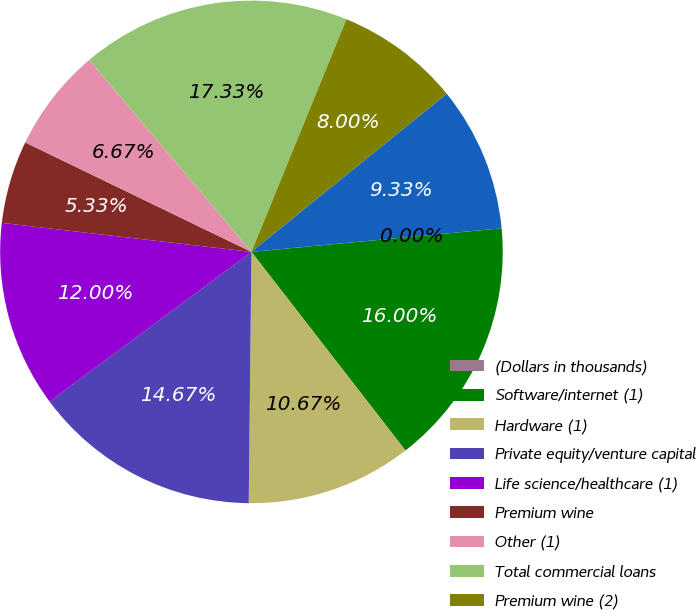Convert chart. <chart><loc_0><loc_0><loc_500><loc_500><pie_chart><fcel>(Dollars in thousands)<fcel>Software/internet (1)<fcel>Hardware (1)<fcel>Private equity/venture capital<fcel>Life science/healthcare (1)<fcel>Premium wine<fcel>Other (1)<fcel>Total commercial loans<fcel>Premium wine (2)<fcel>Consumer loans (3)<nl><fcel>0.0%<fcel>16.0%<fcel>10.67%<fcel>14.67%<fcel>12.0%<fcel>5.33%<fcel>6.67%<fcel>17.33%<fcel>8.0%<fcel>9.33%<nl></chart> 